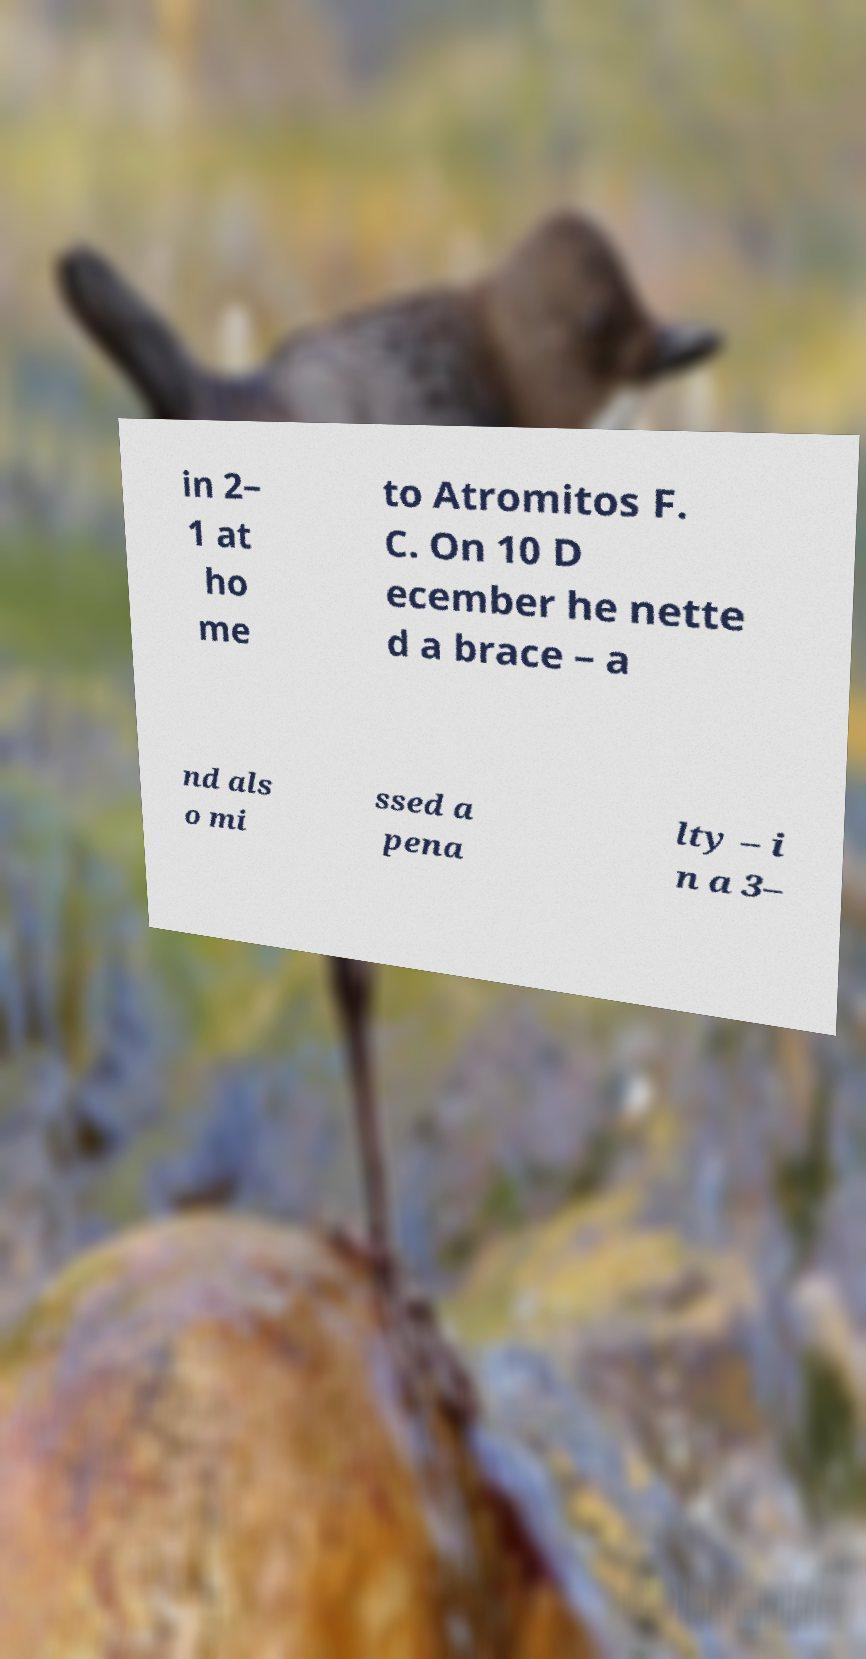I need the written content from this picture converted into text. Can you do that? in 2– 1 at ho me to Atromitos F. C. On 10 D ecember he nette d a brace – a nd als o mi ssed a pena lty – i n a 3– 